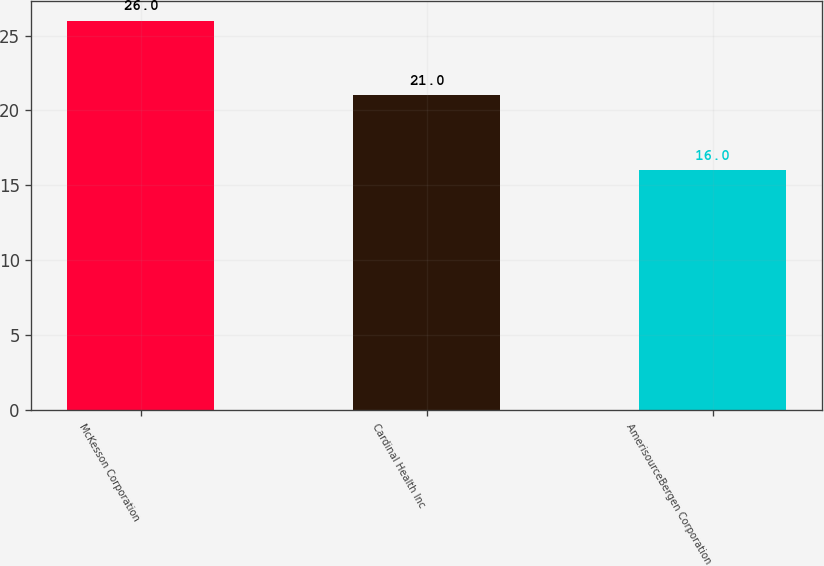<chart> <loc_0><loc_0><loc_500><loc_500><bar_chart><fcel>McKesson Corporation<fcel>Cardinal Health Inc<fcel>AmerisourceBergen Corporation<nl><fcel>26<fcel>21<fcel>16<nl></chart> 